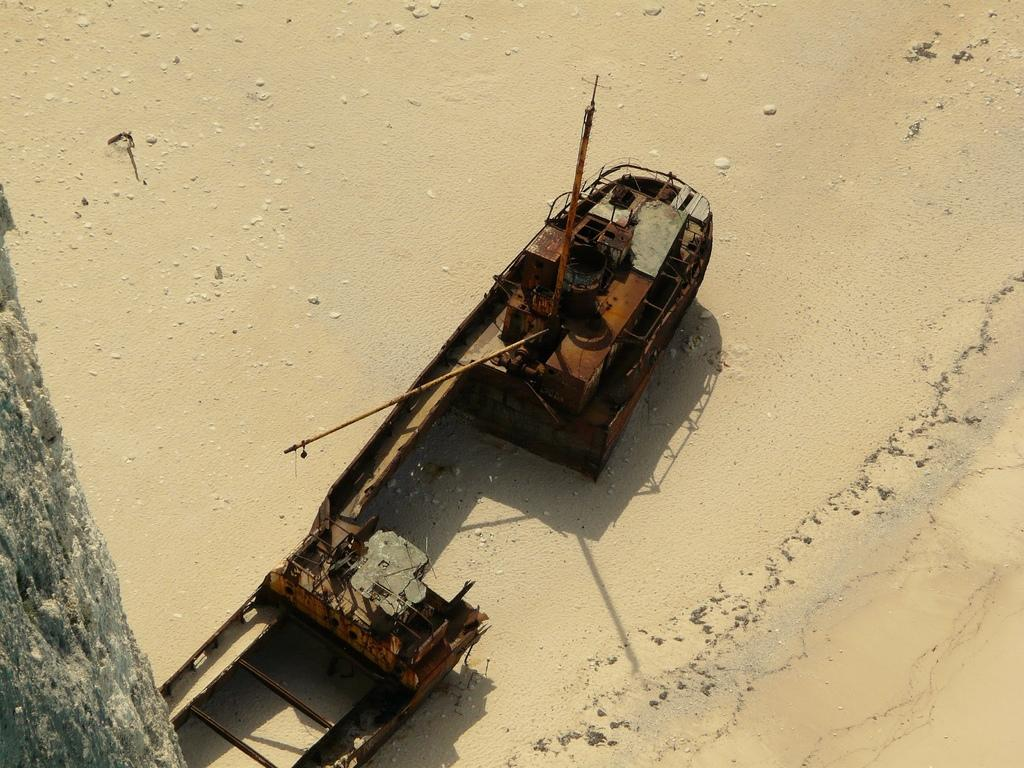What type of structure can be seen on the sand in the image? There is a metal structure on the surface of the sand. What other natural element is present in the image? There is a stem of a tree on the left side of the image. How many properties are for sale in the image? There is no information about properties for sale in the image; it features a metal structure on the sand and a stem of a tree. What type of needle can be seen in the image? There is no needle present in the image. 